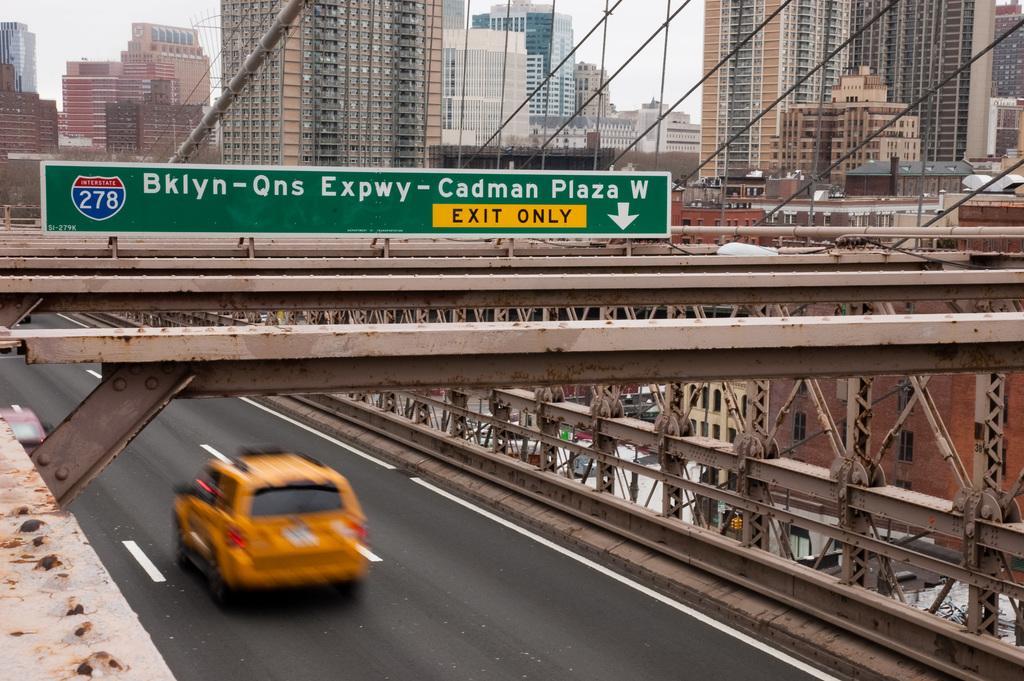Describe this image in one or two sentences. In this image, we can see a car on the bridge. There are some buildings at the top of the image. There is a board in the middle of the image. 